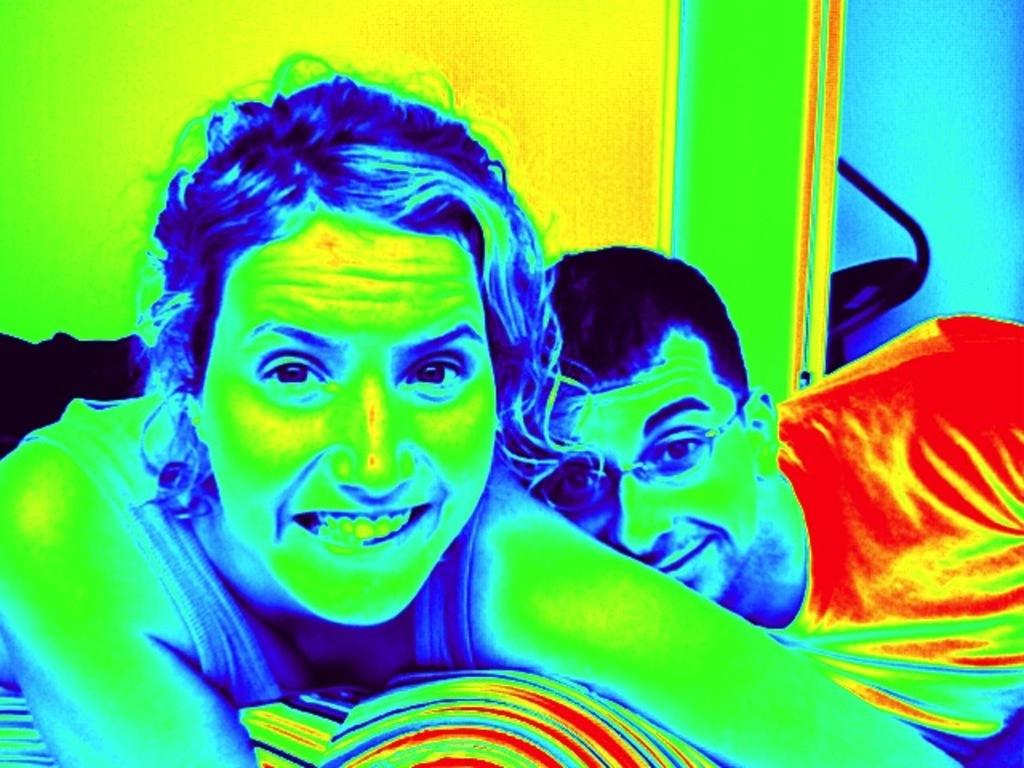How many people are in the image? There are two people in the image. Can you describe the gender of the people in the image? One person is a man, and the other person is a woman. What are the people in the image doing? The two people are posing for the picture. Has the image been altered in any way? Yes, the image has been edited. How many snails can be seen crawling on the woman's face in the image? There are no snails visible in the image, as it features two people posing for a picture. What color are the eyes of the man in the image? The facts provided do not mention the color of the man's eyes, so it cannot be determined from the image. 